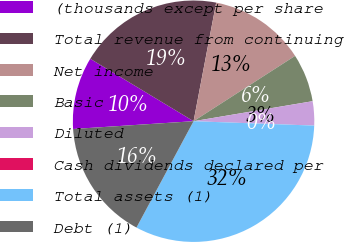Convert chart. <chart><loc_0><loc_0><loc_500><loc_500><pie_chart><fcel>(thousands except per share<fcel>Total revenue from continuing<fcel>Net income<fcel>Basic<fcel>Diluted<fcel>Cash dividends declared per<fcel>Total assets (1)<fcel>Debt (1)<nl><fcel>9.68%<fcel>19.35%<fcel>12.9%<fcel>6.45%<fcel>3.23%<fcel>0.0%<fcel>32.26%<fcel>16.13%<nl></chart> 